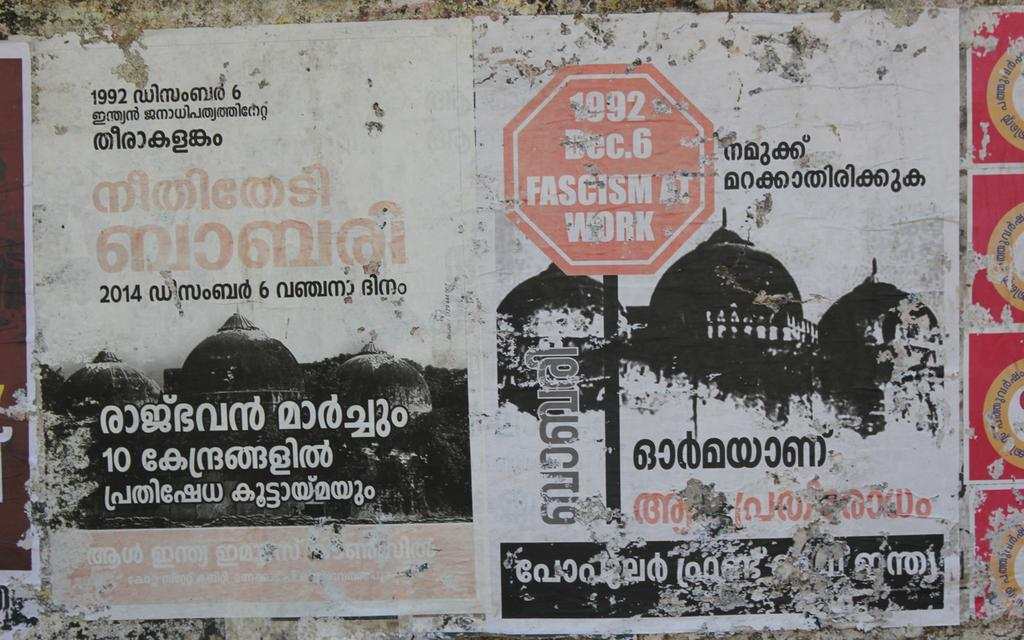<image>
Describe the image concisely. flyers on a wall with one that says '1992' on it 